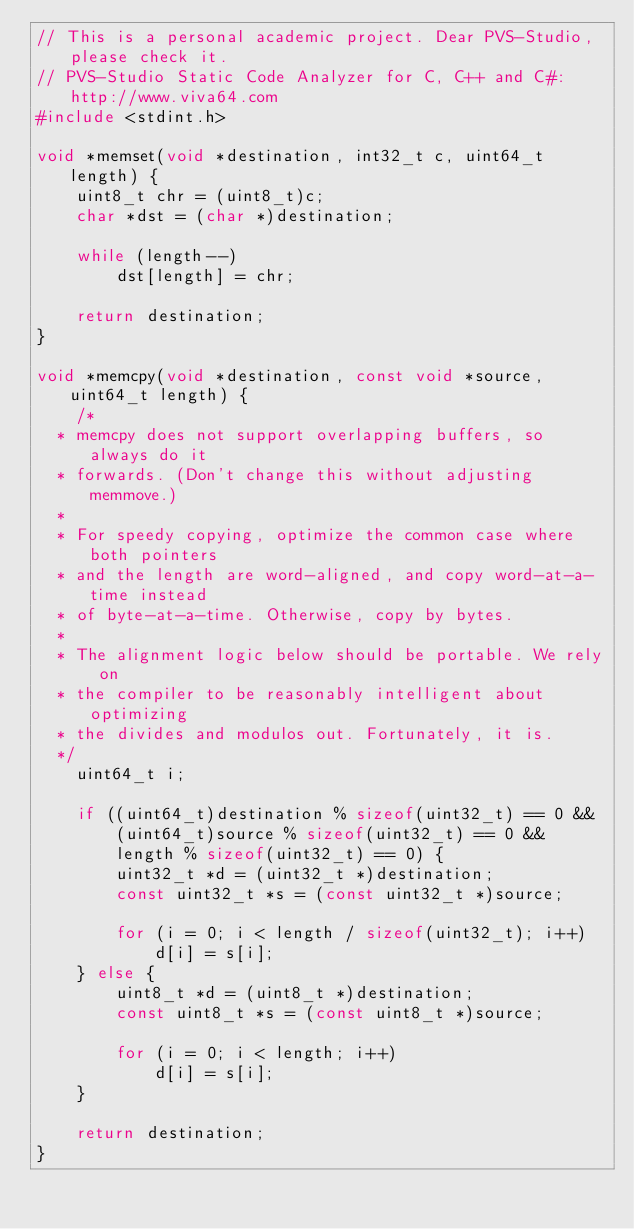<code> <loc_0><loc_0><loc_500><loc_500><_C_>// This is a personal academic project. Dear PVS-Studio, please check it.
// PVS-Studio Static Code Analyzer for C, C++ and C#: http://www.viva64.com
#include <stdint.h>

void *memset(void *destination, int32_t c, uint64_t length) {
    uint8_t chr = (uint8_t)c;
    char *dst = (char *)destination;

    while (length--)
        dst[length] = chr;

    return destination;
}

void *memcpy(void *destination, const void *source, uint64_t length) {
    /*
	* memcpy does not support overlapping buffers, so always do it
	* forwards. (Don't change this without adjusting memmove.)
	*
	* For speedy copying, optimize the common case where both pointers
	* and the length are word-aligned, and copy word-at-a-time instead
	* of byte-at-a-time. Otherwise, copy by bytes.
	*
	* The alignment logic below should be portable. We rely on
	* the compiler to be reasonably intelligent about optimizing
	* the divides and modulos out. Fortunately, it is.
	*/
    uint64_t i;

    if ((uint64_t)destination % sizeof(uint32_t) == 0 &&
        (uint64_t)source % sizeof(uint32_t) == 0 &&
        length % sizeof(uint32_t) == 0) {
        uint32_t *d = (uint32_t *)destination;
        const uint32_t *s = (const uint32_t *)source;

        for (i = 0; i < length / sizeof(uint32_t); i++)
            d[i] = s[i];
    } else {
        uint8_t *d = (uint8_t *)destination;
        const uint8_t *s = (const uint8_t *)source;

        for (i = 0; i < length; i++)
            d[i] = s[i];
    }

    return destination;
}
</code> 